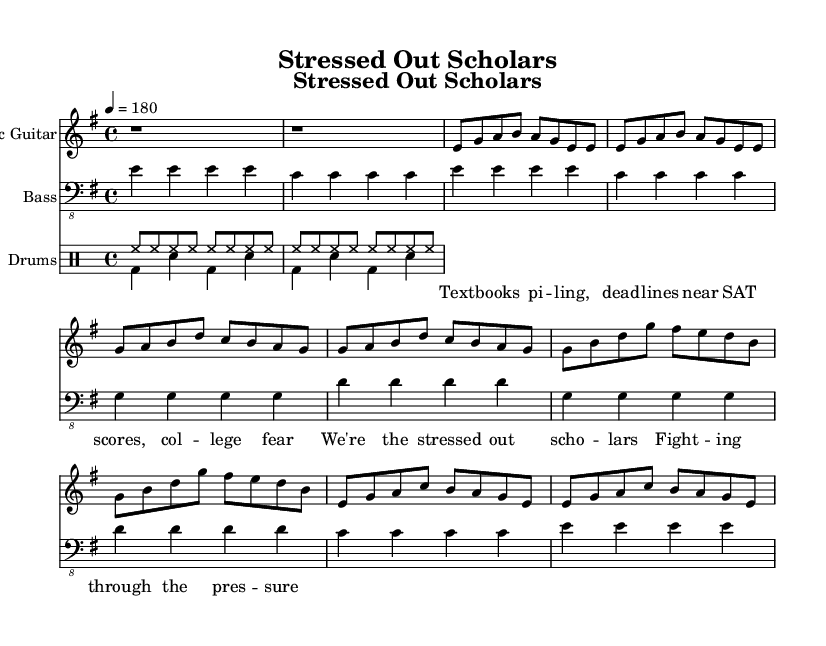What is the key signature of this music? The key signature is E minor, which has one sharp (F#). This can be identified in the key signature section at the beginning of the sheet music.
Answer: E minor What is the time signature of this music? The time signature is 4/4, indicating that there are four beats in each measure, and the quarter note gets one beat. This is displayed at the start of the piece.
Answer: 4/4 What is the tempo marking for this music? The tempo is marked as 180 beats per minute. This can be found in the tempo indication at the beginning of the score, which is set as a quarter note equals 180.
Answer: 180 How many measures are in the verse section? The verse section consists of four measures, which can be counted by observing the grouping of notes in the "Verse" section of the electric guitar part.
Answer: 4 Identify the lyrical theme of the song. The lyrics focus on academic pressure and stress related to college applications, evident from phrases like "SAT scores" and "college fear." This theme resonates with the high-energy punk rock style.
Answer: Academic pressure What instruments are featured in this arrangement? The arrangement features electric guitar, bass, and drums, as indicated by the labeled staves in the score. Each staff corresponds to one of these instruments.
Answer: Electric guitar, bass, drums What type of song structure does this piece represent? This piece follows a basic song structure typical in punk, including verses and a chorus, as shown in the layout of the different sections in the sheet music.
Answer: Verse-Chorus form 